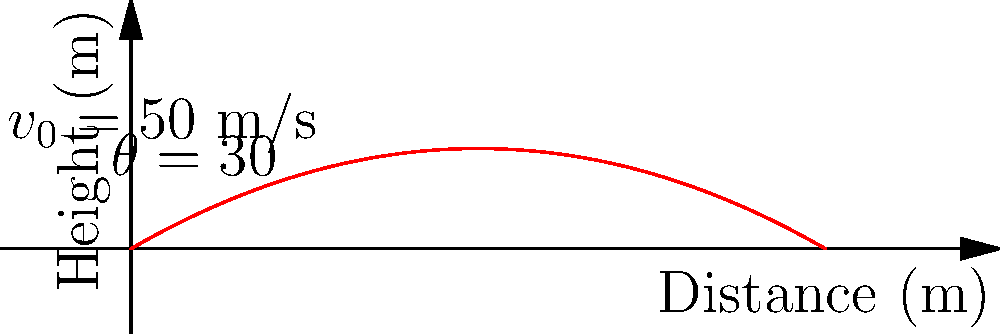As the head of the local disaster response committee, you need to calculate the maximum height reached by a rescue helicopter during an emergency operation. The helicopter takes off with an initial velocity of 50 m/s at an angle of 30° above the horizontal. Assuming no air resistance, what is the maximum height reached by the helicopter? (Use g = 9.8 m/s²) To solve this problem, we'll use the equations of motion for projectile motion:

1. The vertical component of the initial velocity:
   $v_{0y} = v_0 \sin(\theta) = 50 \sin(30°) = 25$ m/s

2. The time to reach maximum height is when the vertical velocity becomes zero:
   $t_{max} = \frac{v_{0y}}{g} = \frac{25}{9.8} = 2.55$ s

3. The maximum height can be calculated using the equation:
   $h_{max} = v_{0y}t - \frac{1}{2}gt^2$

4. Substituting the values:
   $h_{max} = (25)(2.55) - \frac{1}{2}(9.8)(2.55)^2$
   $h_{max} = 63.75 - 31.875 = 31.875$ m

5. Rounding to two decimal places:
   $h_{max} = 31.88$ m

This calculation helps ensure the helicopter's trajectory is within safe operating limits for emergency operations.
Answer: 31.88 m 